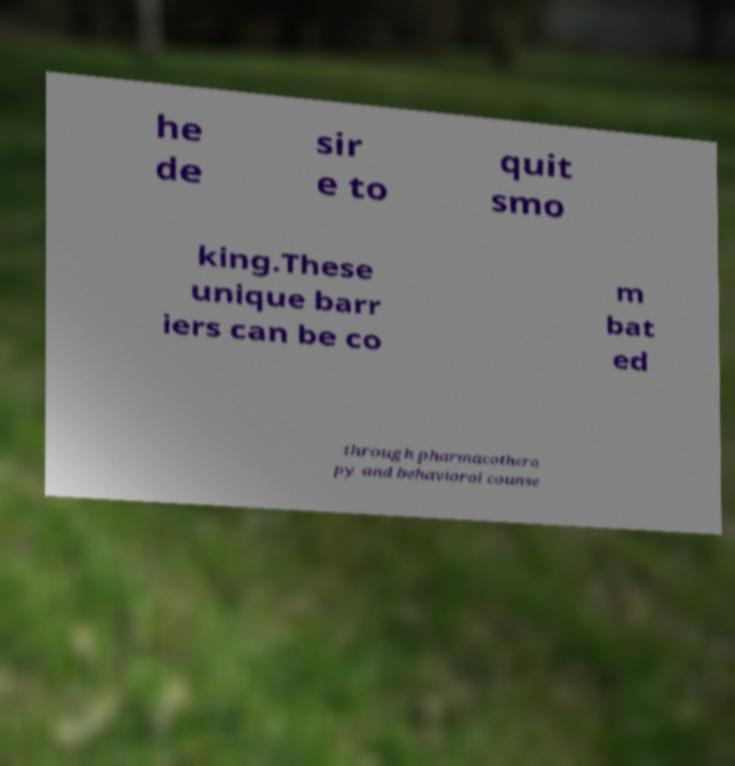Can you read and provide the text displayed in the image?This photo seems to have some interesting text. Can you extract and type it out for me? he de sir e to quit smo king.These unique barr iers can be co m bat ed through pharmacothera py and behavioral counse 